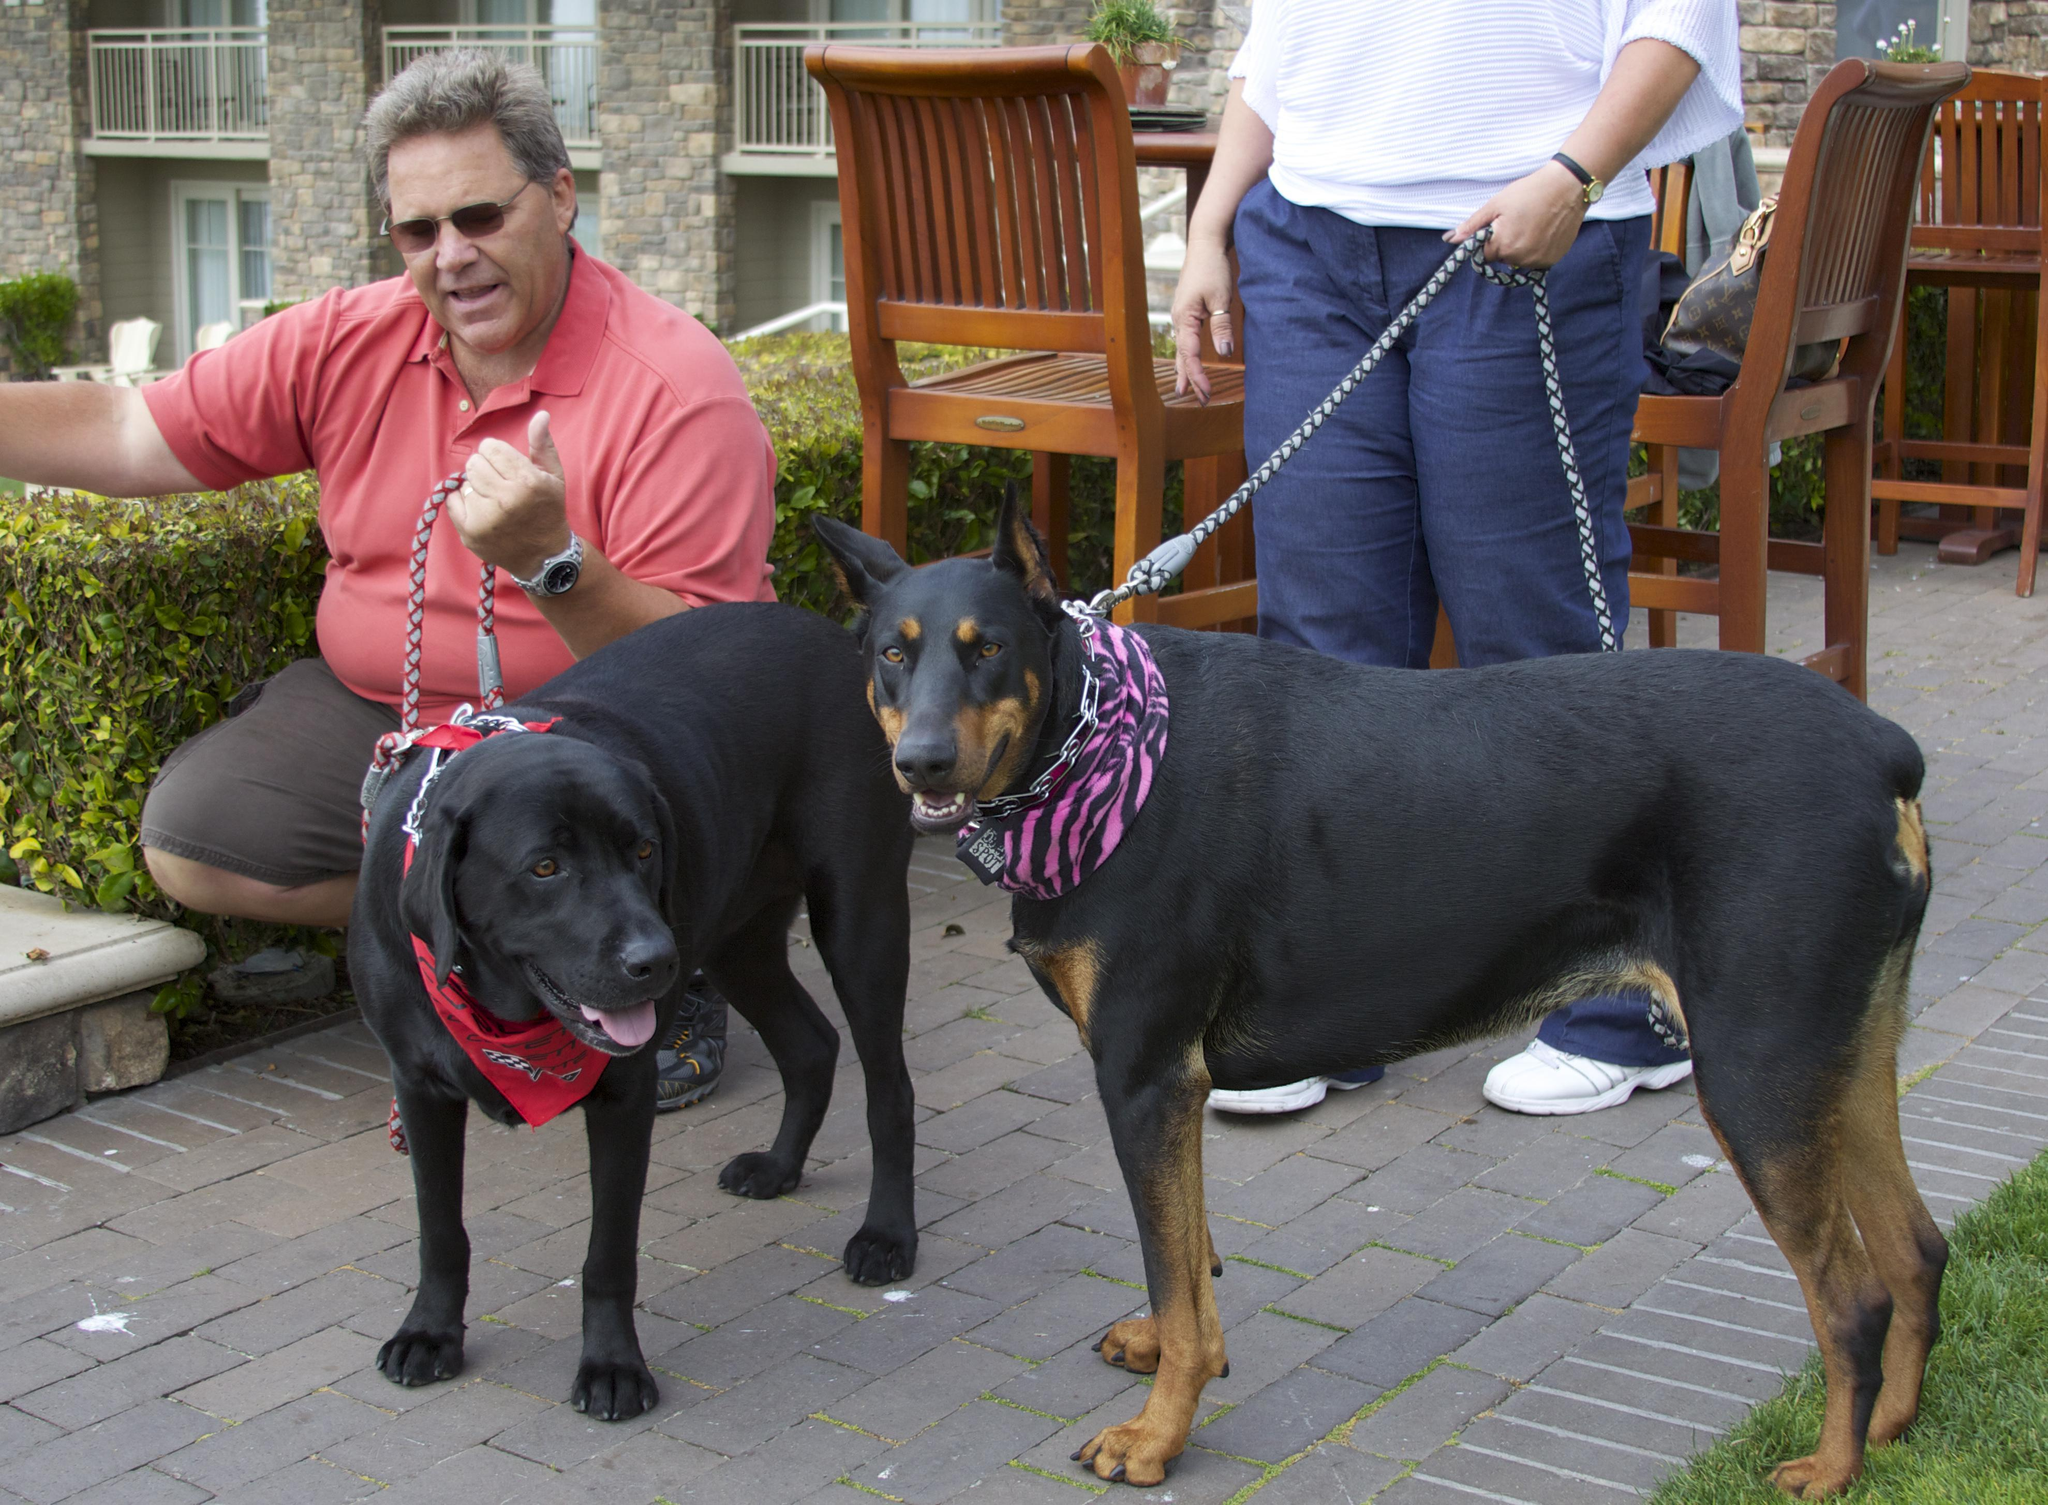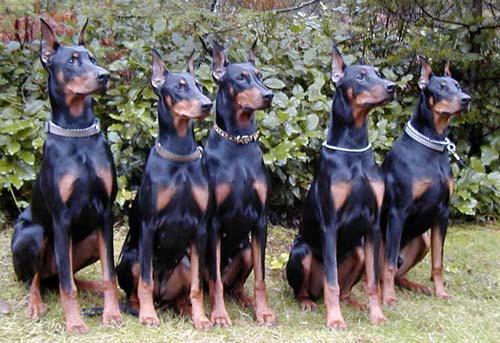The first image is the image on the left, the second image is the image on the right. For the images shown, is this caption "there are 5 dogs sitting in a row on the grass while wearing collars" true? Answer yes or no. Yes. 